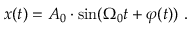Convert formula to latex. <formula><loc_0><loc_0><loc_500><loc_500>x ( t ) = A _ { 0 } \cdot { \sin } ( \Omega _ { 0 } t + \varphi ( t ) ) .</formula> 